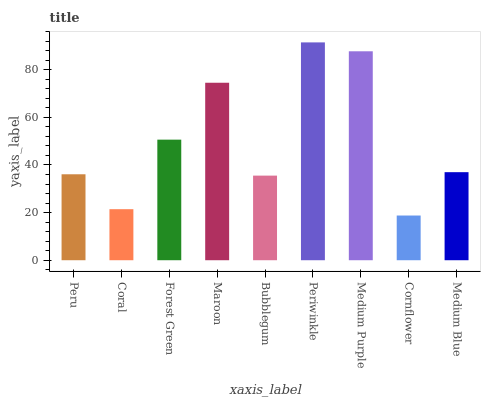Is Coral the minimum?
Answer yes or no. No. Is Coral the maximum?
Answer yes or no. No. Is Peru greater than Coral?
Answer yes or no. Yes. Is Coral less than Peru?
Answer yes or no. Yes. Is Coral greater than Peru?
Answer yes or no. No. Is Peru less than Coral?
Answer yes or no. No. Is Medium Blue the high median?
Answer yes or no. Yes. Is Medium Blue the low median?
Answer yes or no. Yes. Is Coral the high median?
Answer yes or no. No. Is Forest Green the low median?
Answer yes or no. No. 